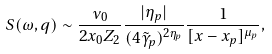Convert formula to latex. <formula><loc_0><loc_0><loc_500><loc_500>S ( \omega , q ) \sim \frac { \nu _ { 0 } } { 2 x _ { 0 } Z _ { 2 } } \frac { | \eta _ { p } | } { ( 4 \tilde { \gamma } _ { p } ) ^ { 2 \eta _ { p } } } \frac { 1 } { [ x - x _ { p } ] ^ { \mu _ { p } } } ,</formula> 